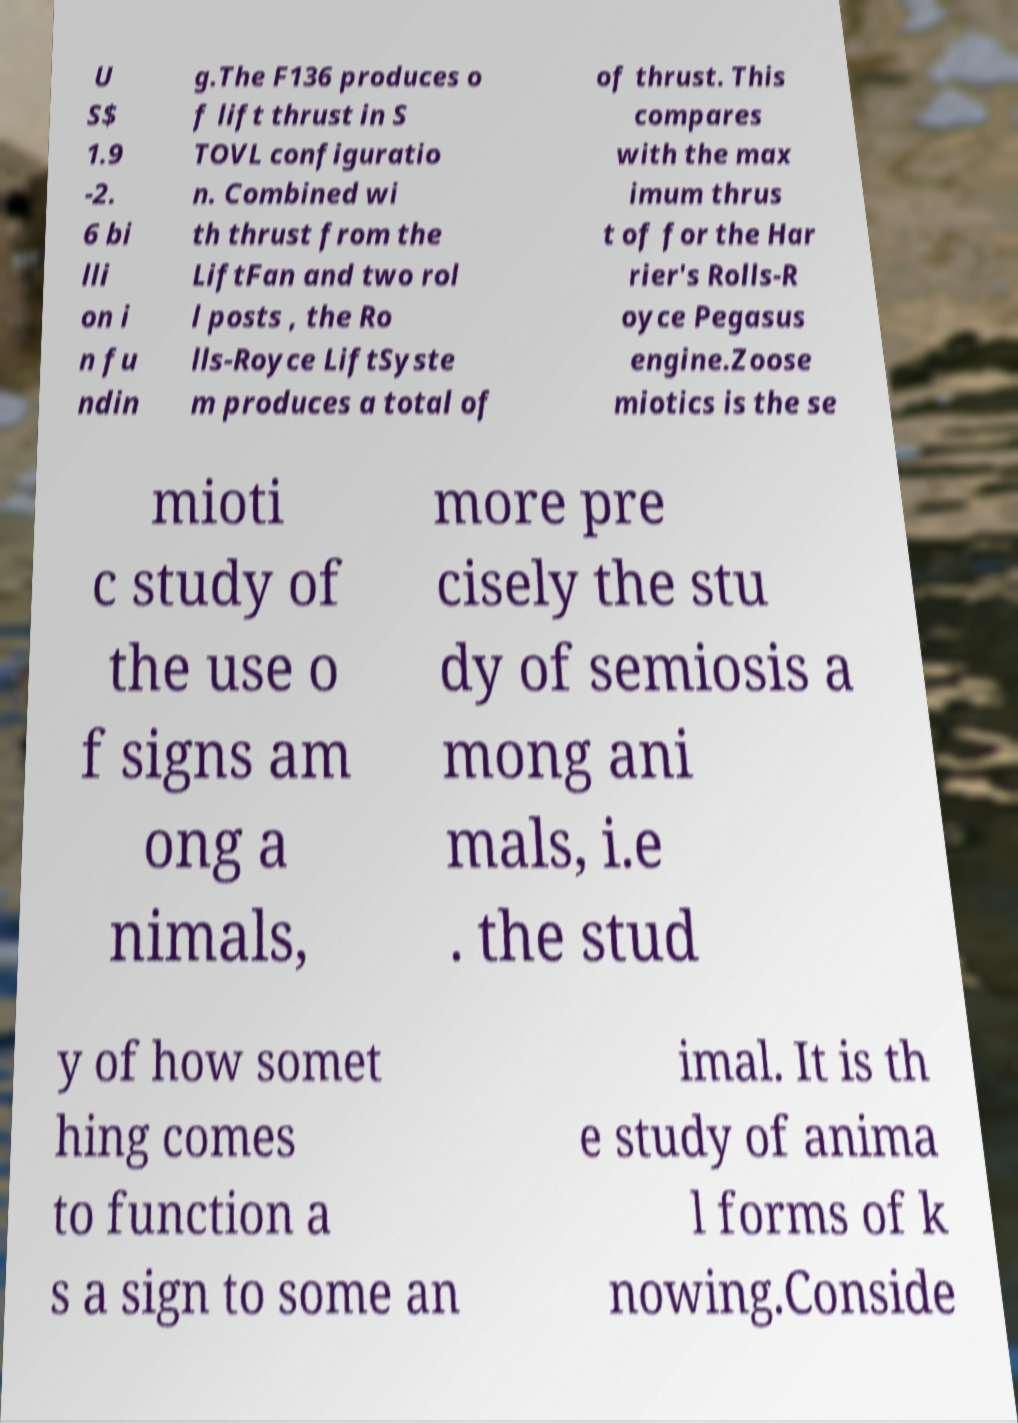Can you read and provide the text displayed in the image?This photo seems to have some interesting text. Can you extract and type it out for me? U S$ 1.9 -2. 6 bi lli on i n fu ndin g.The F136 produces o f lift thrust in S TOVL configuratio n. Combined wi th thrust from the LiftFan and two rol l posts , the Ro lls-Royce LiftSyste m produces a total of of thrust. This compares with the max imum thrus t of for the Har rier's Rolls-R oyce Pegasus engine.Zoose miotics is the se mioti c study of the use o f signs am ong a nimals, more pre cisely the stu dy of semiosis a mong ani mals, i.e . the stud y of how somet hing comes to function a s a sign to some an imal. It is th e study of anima l forms of k nowing.Conside 